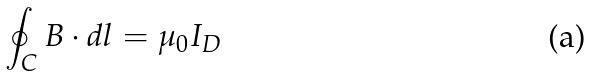Convert formula to latex. <formula><loc_0><loc_0><loc_500><loc_500>\oint _ { C } B \cdot d l = \mu _ { 0 } I _ { D }</formula> 